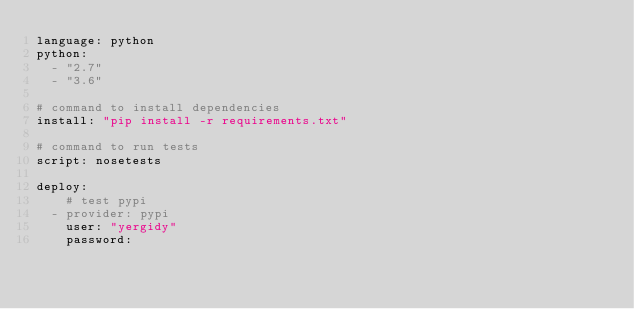Convert code to text. <code><loc_0><loc_0><loc_500><loc_500><_YAML_>language: python
python:
  - "2.7"
  - "3.6"

# command to install dependencies
install: "pip install -r requirements.txt"

# command to run tests
script: nosetests

deploy:
    # test pypi
  - provider: pypi
    user: "yergidy"
    password:</code> 